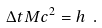<formula> <loc_0><loc_0><loc_500><loc_500>\Delta t M c ^ { 2 } = h \ .</formula> 